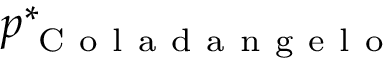Convert formula to latex. <formula><loc_0><loc_0><loc_500><loc_500>p _ { C o l a d a n g e l o } ^ { * }</formula> 